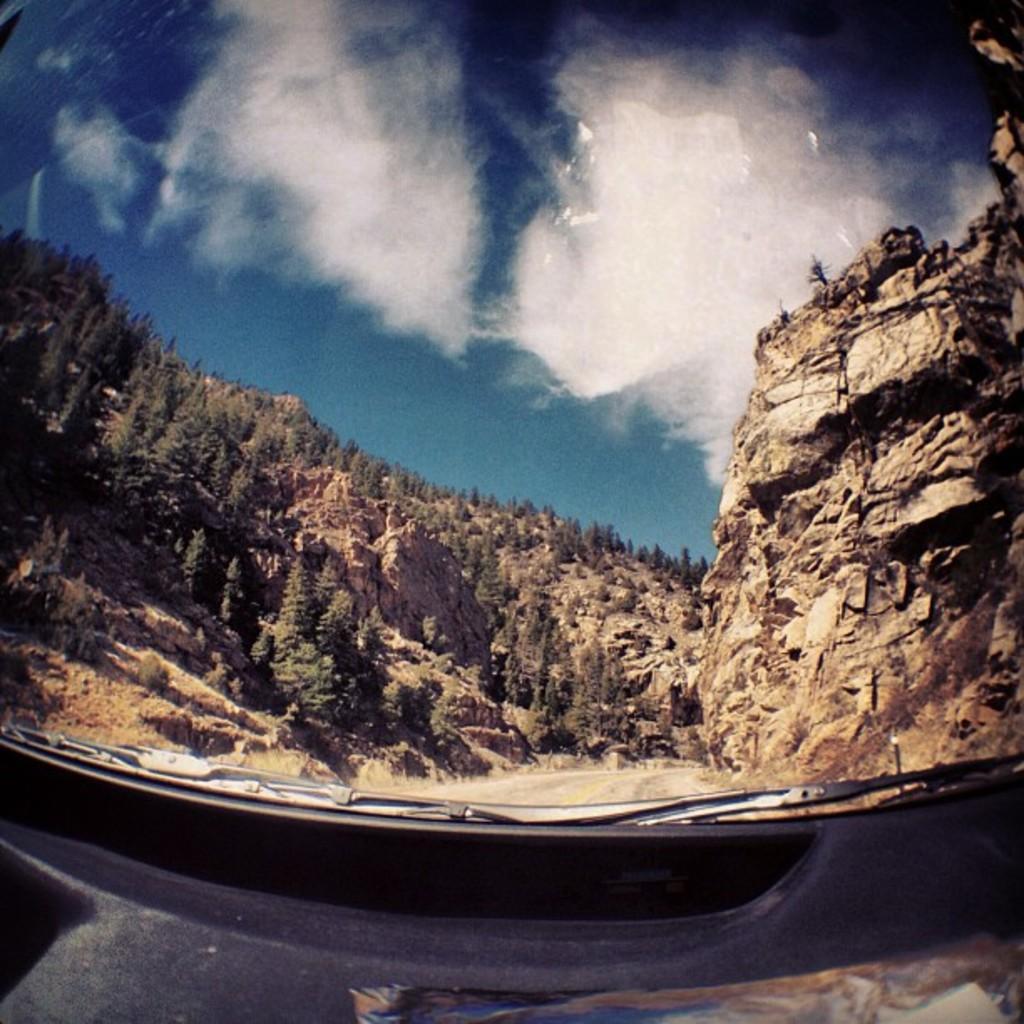In one or two sentences, can you explain what this image depicts? This picture might be taken from outside of the glass window, outside of the glass window, on the right side, we can see some rocks, trees, plants. On the left side, we can see some rocks, trees, plants. At the top, we can see a sky. 